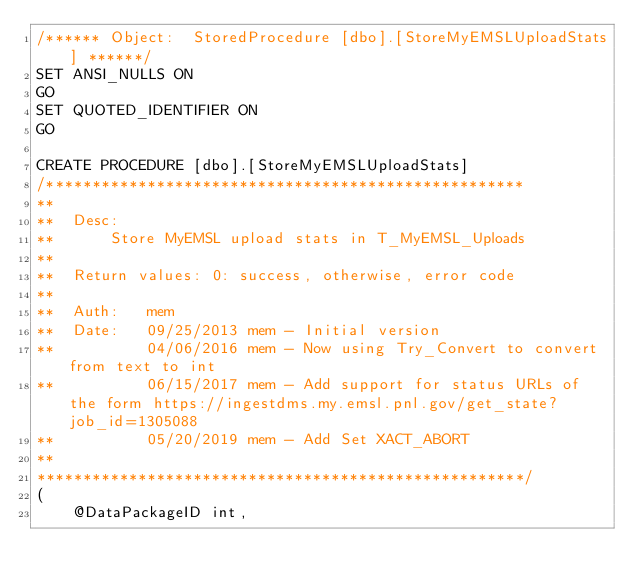<code> <loc_0><loc_0><loc_500><loc_500><_SQL_>/****** Object:  StoredProcedure [dbo].[StoreMyEMSLUploadStats] ******/
SET ANSI_NULLS ON
GO
SET QUOTED_IDENTIFIER ON
GO

CREATE PROCEDURE [dbo].[StoreMyEMSLUploadStats]
/****************************************************
**
**  Desc: 
**      Store MyEMSL upload stats in T_MyEMSL_Uploads
**    
**  Return values: 0: success, otherwise, error code
**
**  Auth:   mem
**  Date:   09/25/2013 mem - Initial version
**          04/06/2016 mem - Now using Try_Convert to convert from text to int
**          06/15/2017 mem - Add support for status URLs of the form https://ingestdms.my.emsl.pnl.gov/get_state?job_id=1305088
**          05/20/2019 mem - Add Set XACT_ABORT
**    
*****************************************************/
(
    @DataPackageID int,</code> 